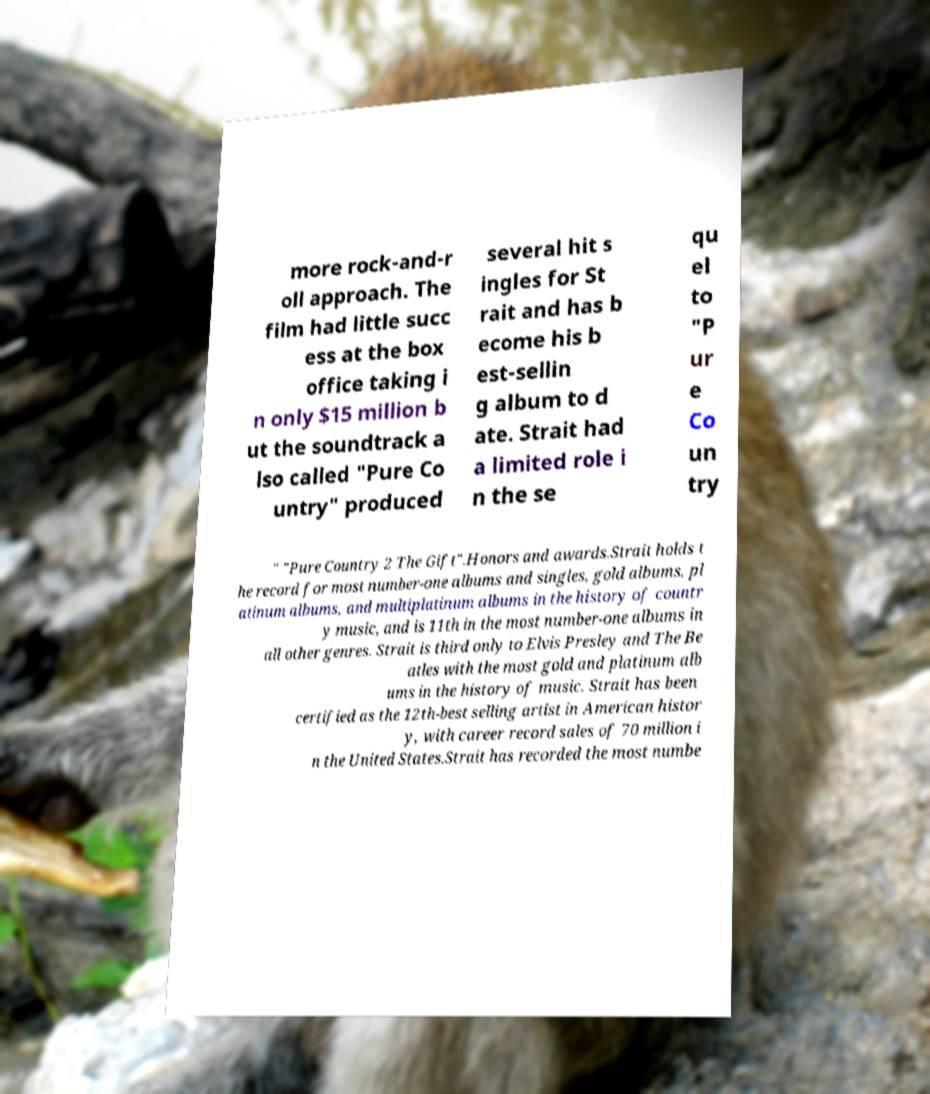Please identify and transcribe the text found in this image. more rock-and-r oll approach. The film had little succ ess at the box office taking i n only $15 million b ut the soundtrack a lso called "Pure Co untry" produced several hit s ingles for St rait and has b ecome his b est-sellin g album to d ate. Strait had a limited role i n the se qu el to "P ur e Co un try " "Pure Country 2 The Gift".Honors and awards.Strait holds t he record for most number-one albums and singles, gold albums, pl atinum albums, and multiplatinum albums in the history of countr y music, and is 11th in the most number-one albums in all other genres. Strait is third only to Elvis Presley and The Be atles with the most gold and platinum alb ums in the history of music. Strait has been certified as the 12th-best selling artist in American histor y, with career record sales of 70 million i n the United States.Strait has recorded the most numbe 